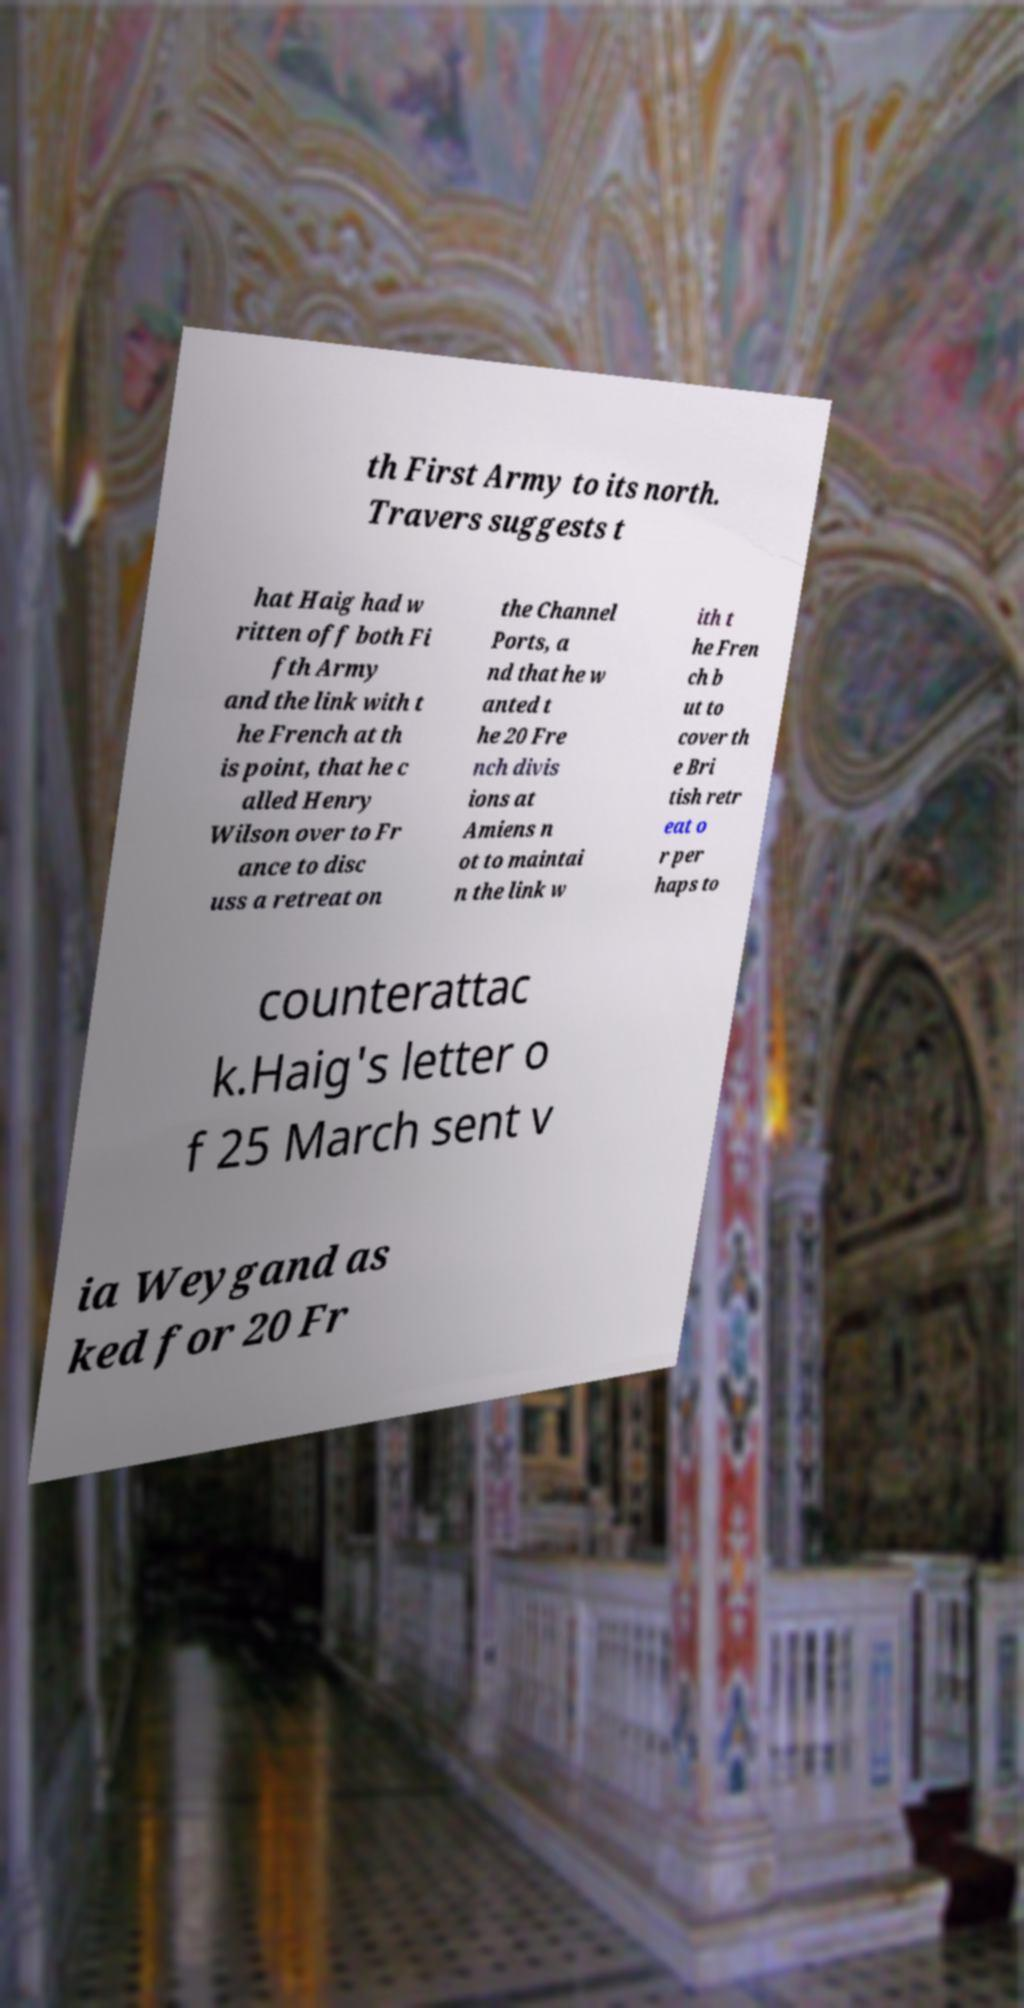Please identify and transcribe the text found in this image. th First Army to its north. Travers suggests t hat Haig had w ritten off both Fi fth Army and the link with t he French at th is point, that he c alled Henry Wilson over to Fr ance to disc uss a retreat on the Channel Ports, a nd that he w anted t he 20 Fre nch divis ions at Amiens n ot to maintai n the link w ith t he Fren ch b ut to cover th e Bri tish retr eat o r per haps to counterattac k.Haig's letter o f 25 March sent v ia Weygand as ked for 20 Fr 